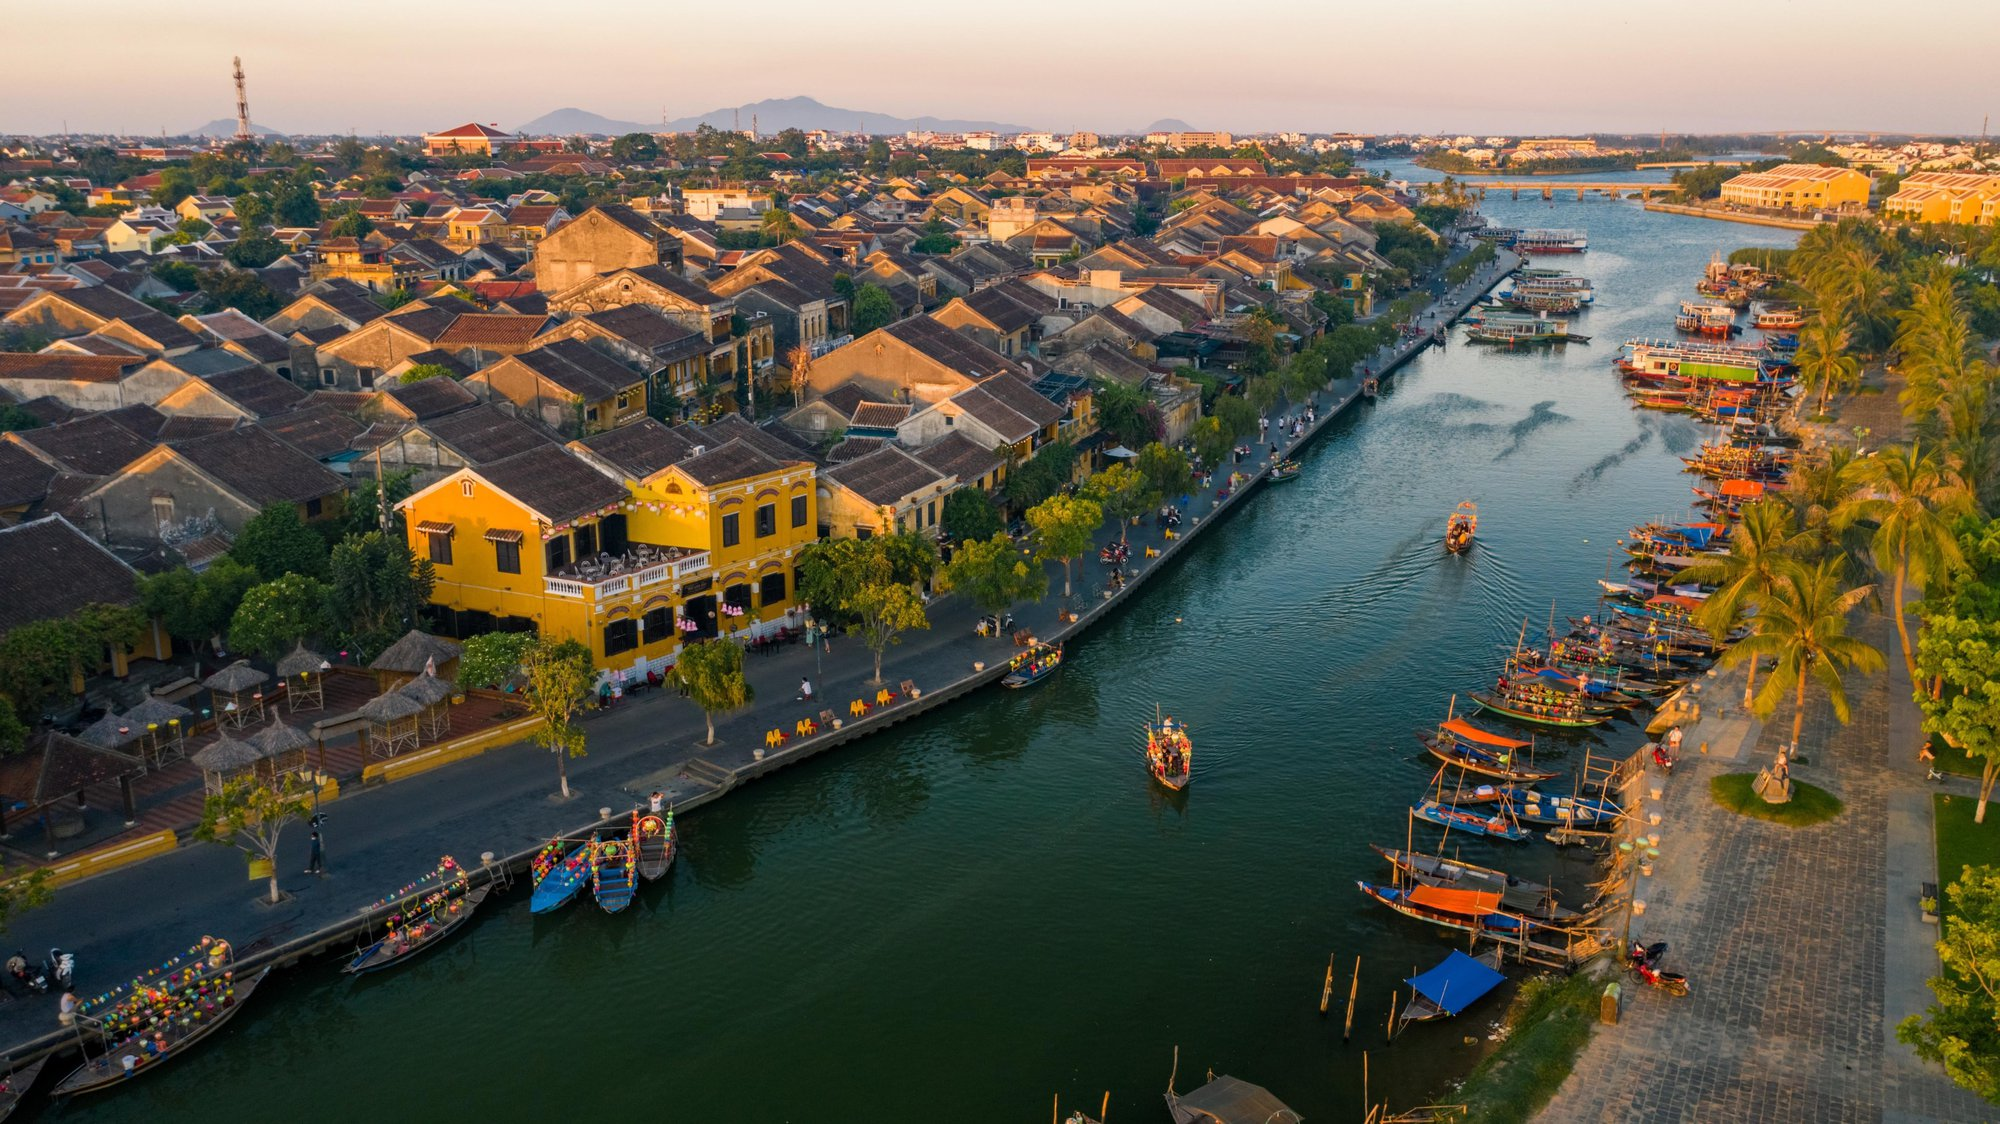Imagine a local festival taking place on the river. Describe the scene. During the festival, the river is alive with color and light. Scores of boats decorated with lanterns, flowers, and traditional banners float on the water, casting a magical glow. The banks of the river are crowded with people, dressed in vibrant traditional attire, who have gathered to enjoy the festivities. Stalls selling local delicacies, crafts, and souvenirs line the streets, and the air is filled with the sounds of laughter, music, and the scent of delicious food. Traditional music performances and dances take place on makeshift stages along the riverbank, while children eagerly participate in games and activities. As night falls, the sky above the river is illuminated with fireworks, reflecting off the water and adding to the enchanting atmosphere. The festival not only showcases the region's rich cultural heritage but also brings the community together in celebration. 